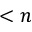<formula> <loc_0><loc_0><loc_500><loc_500>< n</formula> 